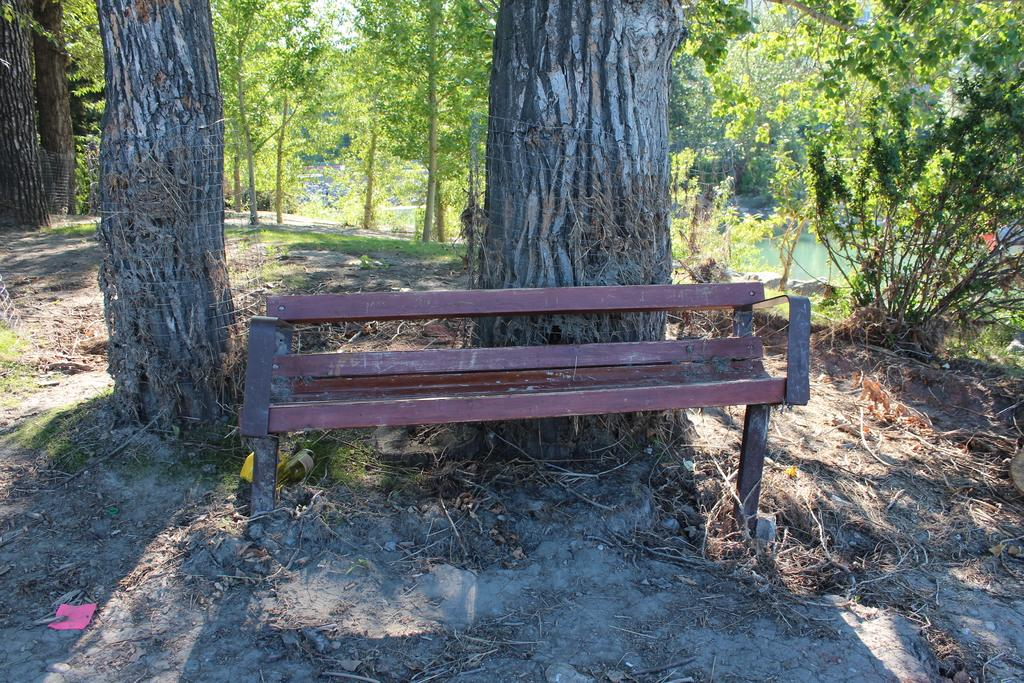What type of seating is in the image? There is a bench in the image. What can be seen in the background of the image? Tree trunks, a mesh, trees, plants, grass, and water are visible in the background. What is on the ground in the image? Twigs and dry leaves are on the ground in the image. Can you tell me how many tables are visible in the image? There are no tables present in the image. What type of ocean can be seen in the image? There is no ocean present in the image. 